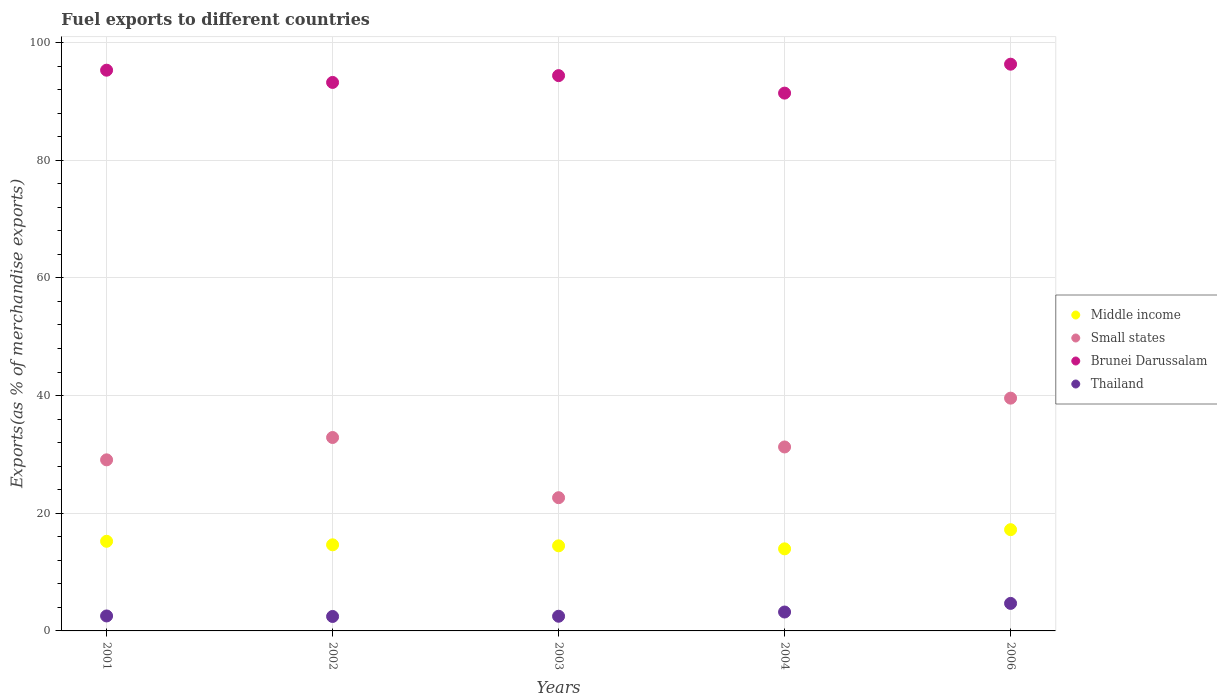How many different coloured dotlines are there?
Give a very brief answer. 4. Is the number of dotlines equal to the number of legend labels?
Provide a short and direct response. Yes. What is the percentage of exports to different countries in Thailand in 2006?
Your answer should be very brief. 4.68. Across all years, what is the maximum percentage of exports to different countries in Thailand?
Your response must be concise. 4.68. Across all years, what is the minimum percentage of exports to different countries in Brunei Darussalam?
Your response must be concise. 91.41. In which year was the percentage of exports to different countries in Brunei Darussalam maximum?
Your answer should be very brief. 2006. What is the total percentage of exports to different countries in Brunei Darussalam in the graph?
Your answer should be compact. 470.65. What is the difference between the percentage of exports to different countries in Thailand in 2001 and that in 2003?
Your answer should be very brief. 0.05. What is the difference between the percentage of exports to different countries in Small states in 2006 and the percentage of exports to different countries in Middle income in 2002?
Ensure brevity in your answer.  24.93. What is the average percentage of exports to different countries in Thailand per year?
Your response must be concise. 3.08. In the year 2006, what is the difference between the percentage of exports to different countries in Brunei Darussalam and percentage of exports to different countries in Thailand?
Offer a very short reply. 91.65. In how many years, is the percentage of exports to different countries in Brunei Darussalam greater than 88 %?
Provide a succinct answer. 5. What is the ratio of the percentage of exports to different countries in Middle income in 2003 to that in 2004?
Your answer should be very brief. 1.04. Is the percentage of exports to different countries in Thailand in 2003 less than that in 2006?
Your answer should be very brief. Yes. Is the difference between the percentage of exports to different countries in Brunei Darussalam in 2002 and 2003 greater than the difference between the percentage of exports to different countries in Thailand in 2002 and 2003?
Your answer should be compact. No. What is the difference between the highest and the second highest percentage of exports to different countries in Brunei Darussalam?
Keep it short and to the point. 1.02. What is the difference between the highest and the lowest percentage of exports to different countries in Thailand?
Offer a terse response. 2.22. In how many years, is the percentage of exports to different countries in Thailand greater than the average percentage of exports to different countries in Thailand taken over all years?
Provide a succinct answer. 2. Is it the case that in every year, the sum of the percentage of exports to different countries in Middle income and percentage of exports to different countries in Small states  is greater than the sum of percentage of exports to different countries in Thailand and percentage of exports to different countries in Brunei Darussalam?
Make the answer very short. Yes. Is the percentage of exports to different countries in Middle income strictly greater than the percentage of exports to different countries in Small states over the years?
Your answer should be very brief. No. Is the percentage of exports to different countries in Small states strictly less than the percentage of exports to different countries in Middle income over the years?
Make the answer very short. No. How many years are there in the graph?
Offer a terse response. 5. What is the difference between two consecutive major ticks on the Y-axis?
Your answer should be very brief. 20. Does the graph contain any zero values?
Keep it short and to the point. No. Does the graph contain grids?
Keep it short and to the point. Yes. Where does the legend appear in the graph?
Keep it short and to the point. Center right. How are the legend labels stacked?
Make the answer very short. Vertical. What is the title of the graph?
Ensure brevity in your answer.  Fuel exports to different countries. Does "Maldives" appear as one of the legend labels in the graph?
Offer a terse response. No. What is the label or title of the Y-axis?
Offer a very short reply. Exports(as % of merchandise exports). What is the Exports(as % of merchandise exports) of Middle income in 2001?
Your response must be concise. 15.23. What is the Exports(as % of merchandise exports) in Small states in 2001?
Offer a very short reply. 29.08. What is the Exports(as % of merchandise exports) of Brunei Darussalam in 2001?
Ensure brevity in your answer.  95.31. What is the Exports(as % of merchandise exports) of Thailand in 2001?
Ensure brevity in your answer.  2.54. What is the Exports(as % of merchandise exports) in Middle income in 2002?
Offer a terse response. 14.63. What is the Exports(as % of merchandise exports) of Small states in 2002?
Your answer should be compact. 32.88. What is the Exports(as % of merchandise exports) of Brunei Darussalam in 2002?
Give a very brief answer. 93.23. What is the Exports(as % of merchandise exports) of Thailand in 2002?
Your answer should be compact. 2.46. What is the Exports(as % of merchandise exports) of Middle income in 2003?
Provide a succinct answer. 14.46. What is the Exports(as % of merchandise exports) of Small states in 2003?
Your answer should be very brief. 22.64. What is the Exports(as % of merchandise exports) of Brunei Darussalam in 2003?
Your response must be concise. 94.38. What is the Exports(as % of merchandise exports) of Thailand in 2003?
Provide a succinct answer. 2.5. What is the Exports(as % of merchandise exports) of Middle income in 2004?
Your response must be concise. 13.95. What is the Exports(as % of merchandise exports) in Small states in 2004?
Make the answer very short. 31.27. What is the Exports(as % of merchandise exports) in Brunei Darussalam in 2004?
Your response must be concise. 91.41. What is the Exports(as % of merchandise exports) of Thailand in 2004?
Keep it short and to the point. 3.21. What is the Exports(as % of merchandise exports) of Middle income in 2006?
Your answer should be compact. 17.21. What is the Exports(as % of merchandise exports) of Small states in 2006?
Keep it short and to the point. 39.56. What is the Exports(as % of merchandise exports) of Brunei Darussalam in 2006?
Give a very brief answer. 96.33. What is the Exports(as % of merchandise exports) of Thailand in 2006?
Give a very brief answer. 4.68. Across all years, what is the maximum Exports(as % of merchandise exports) in Middle income?
Provide a short and direct response. 17.21. Across all years, what is the maximum Exports(as % of merchandise exports) in Small states?
Your answer should be very brief. 39.56. Across all years, what is the maximum Exports(as % of merchandise exports) of Brunei Darussalam?
Your response must be concise. 96.33. Across all years, what is the maximum Exports(as % of merchandise exports) in Thailand?
Make the answer very short. 4.68. Across all years, what is the minimum Exports(as % of merchandise exports) of Middle income?
Keep it short and to the point. 13.95. Across all years, what is the minimum Exports(as % of merchandise exports) of Small states?
Offer a very short reply. 22.64. Across all years, what is the minimum Exports(as % of merchandise exports) in Brunei Darussalam?
Make the answer very short. 91.41. Across all years, what is the minimum Exports(as % of merchandise exports) in Thailand?
Give a very brief answer. 2.46. What is the total Exports(as % of merchandise exports) in Middle income in the graph?
Make the answer very short. 75.49. What is the total Exports(as % of merchandise exports) of Small states in the graph?
Provide a short and direct response. 155.43. What is the total Exports(as % of merchandise exports) of Brunei Darussalam in the graph?
Offer a very short reply. 470.65. What is the total Exports(as % of merchandise exports) in Thailand in the graph?
Offer a very short reply. 15.39. What is the difference between the Exports(as % of merchandise exports) of Middle income in 2001 and that in 2002?
Make the answer very short. 0.6. What is the difference between the Exports(as % of merchandise exports) of Small states in 2001 and that in 2002?
Provide a short and direct response. -3.8. What is the difference between the Exports(as % of merchandise exports) in Brunei Darussalam in 2001 and that in 2002?
Your answer should be very brief. 2.08. What is the difference between the Exports(as % of merchandise exports) of Thailand in 2001 and that in 2002?
Ensure brevity in your answer.  0.09. What is the difference between the Exports(as % of merchandise exports) of Middle income in 2001 and that in 2003?
Provide a short and direct response. 0.77. What is the difference between the Exports(as % of merchandise exports) in Small states in 2001 and that in 2003?
Offer a very short reply. 6.43. What is the difference between the Exports(as % of merchandise exports) in Brunei Darussalam in 2001 and that in 2003?
Provide a succinct answer. 0.92. What is the difference between the Exports(as % of merchandise exports) in Thailand in 2001 and that in 2003?
Make the answer very short. 0.05. What is the difference between the Exports(as % of merchandise exports) of Middle income in 2001 and that in 2004?
Offer a terse response. 1.28. What is the difference between the Exports(as % of merchandise exports) in Small states in 2001 and that in 2004?
Offer a terse response. -2.19. What is the difference between the Exports(as % of merchandise exports) of Brunei Darussalam in 2001 and that in 2004?
Make the answer very short. 3.9. What is the difference between the Exports(as % of merchandise exports) of Thailand in 2001 and that in 2004?
Your answer should be very brief. -0.67. What is the difference between the Exports(as % of merchandise exports) in Middle income in 2001 and that in 2006?
Provide a short and direct response. -1.97. What is the difference between the Exports(as % of merchandise exports) in Small states in 2001 and that in 2006?
Ensure brevity in your answer.  -10.49. What is the difference between the Exports(as % of merchandise exports) in Brunei Darussalam in 2001 and that in 2006?
Your response must be concise. -1.02. What is the difference between the Exports(as % of merchandise exports) in Thailand in 2001 and that in 2006?
Give a very brief answer. -2.13. What is the difference between the Exports(as % of merchandise exports) in Middle income in 2002 and that in 2003?
Offer a very short reply. 0.17. What is the difference between the Exports(as % of merchandise exports) of Small states in 2002 and that in 2003?
Offer a terse response. 10.23. What is the difference between the Exports(as % of merchandise exports) in Brunei Darussalam in 2002 and that in 2003?
Keep it short and to the point. -1.16. What is the difference between the Exports(as % of merchandise exports) in Thailand in 2002 and that in 2003?
Give a very brief answer. -0.04. What is the difference between the Exports(as % of merchandise exports) of Middle income in 2002 and that in 2004?
Give a very brief answer. 0.68. What is the difference between the Exports(as % of merchandise exports) in Small states in 2002 and that in 2004?
Offer a terse response. 1.61. What is the difference between the Exports(as % of merchandise exports) in Brunei Darussalam in 2002 and that in 2004?
Your response must be concise. 1.82. What is the difference between the Exports(as % of merchandise exports) in Thailand in 2002 and that in 2004?
Ensure brevity in your answer.  -0.76. What is the difference between the Exports(as % of merchandise exports) in Middle income in 2002 and that in 2006?
Make the answer very short. -2.57. What is the difference between the Exports(as % of merchandise exports) in Small states in 2002 and that in 2006?
Offer a very short reply. -6.69. What is the difference between the Exports(as % of merchandise exports) in Brunei Darussalam in 2002 and that in 2006?
Provide a short and direct response. -3.1. What is the difference between the Exports(as % of merchandise exports) of Thailand in 2002 and that in 2006?
Ensure brevity in your answer.  -2.22. What is the difference between the Exports(as % of merchandise exports) in Middle income in 2003 and that in 2004?
Keep it short and to the point. 0.51. What is the difference between the Exports(as % of merchandise exports) in Small states in 2003 and that in 2004?
Make the answer very short. -8.62. What is the difference between the Exports(as % of merchandise exports) of Brunei Darussalam in 2003 and that in 2004?
Keep it short and to the point. 2.97. What is the difference between the Exports(as % of merchandise exports) in Thailand in 2003 and that in 2004?
Ensure brevity in your answer.  -0.72. What is the difference between the Exports(as % of merchandise exports) in Middle income in 2003 and that in 2006?
Offer a terse response. -2.75. What is the difference between the Exports(as % of merchandise exports) in Small states in 2003 and that in 2006?
Your answer should be compact. -16.92. What is the difference between the Exports(as % of merchandise exports) of Brunei Darussalam in 2003 and that in 2006?
Your answer should be compact. -1.94. What is the difference between the Exports(as % of merchandise exports) in Thailand in 2003 and that in 2006?
Provide a succinct answer. -2.18. What is the difference between the Exports(as % of merchandise exports) in Middle income in 2004 and that in 2006?
Provide a short and direct response. -3.26. What is the difference between the Exports(as % of merchandise exports) of Small states in 2004 and that in 2006?
Give a very brief answer. -8.3. What is the difference between the Exports(as % of merchandise exports) in Brunei Darussalam in 2004 and that in 2006?
Your response must be concise. -4.92. What is the difference between the Exports(as % of merchandise exports) of Thailand in 2004 and that in 2006?
Offer a very short reply. -1.47. What is the difference between the Exports(as % of merchandise exports) in Middle income in 2001 and the Exports(as % of merchandise exports) in Small states in 2002?
Provide a short and direct response. -17.64. What is the difference between the Exports(as % of merchandise exports) in Middle income in 2001 and the Exports(as % of merchandise exports) in Brunei Darussalam in 2002?
Ensure brevity in your answer.  -77.99. What is the difference between the Exports(as % of merchandise exports) in Middle income in 2001 and the Exports(as % of merchandise exports) in Thailand in 2002?
Your response must be concise. 12.78. What is the difference between the Exports(as % of merchandise exports) of Small states in 2001 and the Exports(as % of merchandise exports) of Brunei Darussalam in 2002?
Make the answer very short. -64.15. What is the difference between the Exports(as % of merchandise exports) of Small states in 2001 and the Exports(as % of merchandise exports) of Thailand in 2002?
Offer a terse response. 26.62. What is the difference between the Exports(as % of merchandise exports) in Brunei Darussalam in 2001 and the Exports(as % of merchandise exports) in Thailand in 2002?
Provide a succinct answer. 92.85. What is the difference between the Exports(as % of merchandise exports) in Middle income in 2001 and the Exports(as % of merchandise exports) in Small states in 2003?
Offer a terse response. -7.41. What is the difference between the Exports(as % of merchandise exports) of Middle income in 2001 and the Exports(as % of merchandise exports) of Brunei Darussalam in 2003?
Provide a short and direct response. -79.15. What is the difference between the Exports(as % of merchandise exports) of Middle income in 2001 and the Exports(as % of merchandise exports) of Thailand in 2003?
Keep it short and to the point. 12.74. What is the difference between the Exports(as % of merchandise exports) in Small states in 2001 and the Exports(as % of merchandise exports) in Brunei Darussalam in 2003?
Make the answer very short. -65.3. What is the difference between the Exports(as % of merchandise exports) in Small states in 2001 and the Exports(as % of merchandise exports) in Thailand in 2003?
Give a very brief answer. 26.58. What is the difference between the Exports(as % of merchandise exports) of Brunei Darussalam in 2001 and the Exports(as % of merchandise exports) of Thailand in 2003?
Your response must be concise. 92.81. What is the difference between the Exports(as % of merchandise exports) in Middle income in 2001 and the Exports(as % of merchandise exports) in Small states in 2004?
Provide a short and direct response. -16.03. What is the difference between the Exports(as % of merchandise exports) of Middle income in 2001 and the Exports(as % of merchandise exports) of Brunei Darussalam in 2004?
Give a very brief answer. -76.17. What is the difference between the Exports(as % of merchandise exports) of Middle income in 2001 and the Exports(as % of merchandise exports) of Thailand in 2004?
Give a very brief answer. 12.02. What is the difference between the Exports(as % of merchandise exports) of Small states in 2001 and the Exports(as % of merchandise exports) of Brunei Darussalam in 2004?
Keep it short and to the point. -62.33. What is the difference between the Exports(as % of merchandise exports) in Small states in 2001 and the Exports(as % of merchandise exports) in Thailand in 2004?
Your response must be concise. 25.86. What is the difference between the Exports(as % of merchandise exports) of Brunei Darussalam in 2001 and the Exports(as % of merchandise exports) of Thailand in 2004?
Keep it short and to the point. 92.09. What is the difference between the Exports(as % of merchandise exports) of Middle income in 2001 and the Exports(as % of merchandise exports) of Small states in 2006?
Your answer should be compact. -24.33. What is the difference between the Exports(as % of merchandise exports) of Middle income in 2001 and the Exports(as % of merchandise exports) of Brunei Darussalam in 2006?
Give a very brief answer. -81.09. What is the difference between the Exports(as % of merchandise exports) in Middle income in 2001 and the Exports(as % of merchandise exports) in Thailand in 2006?
Your answer should be compact. 10.56. What is the difference between the Exports(as % of merchandise exports) of Small states in 2001 and the Exports(as % of merchandise exports) of Brunei Darussalam in 2006?
Provide a succinct answer. -67.25. What is the difference between the Exports(as % of merchandise exports) in Small states in 2001 and the Exports(as % of merchandise exports) in Thailand in 2006?
Give a very brief answer. 24.4. What is the difference between the Exports(as % of merchandise exports) in Brunei Darussalam in 2001 and the Exports(as % of merchandise exports) in Thailand in 2006?
Ensure brevity in your answer.  90.63. What is the difference between the Exports(as % of merchandise exports) in Middle income in 2002 and the Exports(as % of merchandise exports) in Small states in 2003?
Your response must be concise. -8.01. What is the difference between the Exports(as % of merchandise exports) of Middle income in 2002 and the Exports(as % of merchandise exports) of Brunei Darussalam in 2003?
Your response must be concise. -79.75. What is the difference between the Exports(as % of merchandise exports) in Middle income in 2002 and the Exports(as % of merchandise exports) in Thailand in 2003?
Keep it short and to the point. 12.14. What is the difference between the Exports(as % of merchandise exports) in Small states in 2002 and the Exports(as % of merchandise exports) in Brunei Darussalam in 2003?
Give a very brief answer. -61.51. What is the difference between the Exports(as % of merchandise exports) in Small states in 2002 and the Exports(as % of merchandise exports) in Thailand in 2003?
Ensure brevity in your answer.  30.38. What is the difference between the Exports(as % of merchandise exports) of Brunei Darussalam in 2002 and the Exports(as % of merchandise exports) of Thailand in 2003?
Your answer should be compact. 90.73. What is the difference between the Exports(as % of merchandise exports) in Middle income in 2002 and the Exports(as % of merchandise exports) in Small states in 2004?
Offer a very short reply. -16.63. What is the difference between the Exports(as % of merchandise exports) in Middle income in 2002 and the Exports(as % of merchandise exports) in Brunei Darussalam in 2004?
Your answer should be compact. -76.77. What is the difference between the Exports(as % of merchandise exports) in Middle income in 2002 and the Exports(as % of merchandise exports) in Thailand in 2004?
Your response must be concise. 11.42. What is the difference between the Exports(as % of merchandise exports) in Small states in 2002 and the Exports(as % of merchandise exports) in Brunei Darussalam in 2004?
Keep it short and to the point. -58.53. What is the difference between the Exports(as % of merchandise exports) in Small states in 2002 and the Exports(as % of merchandise exports) in Thailand in 2004?
Your answer should be compact. 29.66. What is the difference between the Exports(as % of merchandise exports) of Brunei Darussalam in 2002 and the Exports(as % of merchandise exports) of Thailand in 2004?
Give a very brief answer. 90.01. What is the difference between the Exports(as % of merchandise exports) in Middle income in 2002 and the Exports(as % of merchandise exports) in Small states in 2006?
Your answer should be very brief. -24.93. What is the difference between the Exports(as % of merchandise exports) of Middle income in 2002 and the Exports(as % of merchandise exports) of Brunei Darussalam in 2006?
Offer a terse response. -81.69. What is the difference between the Exports(as % of merchandise exports) in Middle income in 2002 and the Exports(as % of merchandise exports) in Thailand in 2006?
Your answer should be compact. 9.96. What is the difference between the Exports(as % of merchandise exports) in Small states in 2002 and the Exports(as % of merchandise exports) in Brunei Darussalam in 2006?
Make the answer very short. -63.45. What is the difference between the Exports(as % of merchandise exports) in Small states in 2002 and the Exports(as % of merchandise exports) in Thailand in 2006?
Your answer should be compact. 28.2. What is the difference between the Exports(as % of merchandise exports) of Brunei Darussalam in 2002 and the Exports(as % of merchandise exports) of Thailand in 2006?
Offer a very short reply. 88.55. What is the difference between the Exports(as % of merchandise exports) of Middle income in 2003 and the Exports(as % of merchandise exports) of Small states in 2004?
Ensure brevity in your answer.  -16.8. What is the difference between the Exports(as % of merchandise exports) of Middle income in 2003 and the Exports(as % of merchandise exports) of Brunei Darussalam in 2004?
Your response must be concise. -76.95. What is the difference between the Exports(as % of merchandise exports) of Middle income in 2003 and the Exports(as % of merchandise exports) of Thailand in 2004?
Offer a very short reply. 11.25. What is the difference between the Exports(as % of merchandise exports) in Small states in 2003 and the Exports(as % of merchandise exports) in Brunei Darussalam in 2004?
Make the answer very short. -68.77. What is the difference between the Exports(as % of merchandise exports) of Small states in 2003 and the Exports(as % of merchandise exports) of Thailand in 2004?
Provide a short and direct response. 19.43. What is the difference between the Exports(as % of merchandise exports) in Brunei Darussalam in 2003 and the Exports(as % of merchandise exports) in Thailand in 2004?
Your answer should be compact. 91.17. What is the difference between the Exports(as % of merchandise exports) of Middle income in 2003 and the Exports(as % of merchandise exports) of Small states in 2006?
Provide a short and direct response. -25.1. What is the difference between the Exports(as % of merchandise exports) in Middle income in 2003 and the Exports(as % of merchandise exports) in Brunei Darussalam in 2006?
Offer a terse response. -81.86. What is the difference between the Exports(as % of merchandise exports) of Middle income in 2003 and the Exports(as % of merchandise exports) of Thailand in 2006?
Give a very brief answer. 9.78. What is the difference between the Exports(as % of merchandise exports) in Small states in 2003 and the Exports(as % of merchandise exports) in Brunei Darussalam in 2006?
Keep it short and to the point. -73.68. What is the difference between the Exports(as % of merchandise exports) in Small states in 2003 and the Exports(as % of merchandise exports) in Thailand in 2006?
Keep it short and to the point. 17.96. What is the difference between the Exports(as % of merchandise exports) of Brunei Darussalam in 2003 and the Exports(as % of merchandise exports) of Thailand in 2006?
Your response must be concise. 89.7. What is the difference between the Exports(as % of merchandise exports) in Middle income in 2004 and the Exports(as % of merchandise exports) in Small states in 2006?
Offer a very short reply. -25.61. What is the difference between the Exports(as % of merchandise exports) of Middle income in 2004 and the Exports(as % of merchandise exports) of Brunei Darussalam in 2006?
Give a very brief answer. -82.38. What is the difference between the Exports(as % of merchandise exports) of Middle income in 2004 and the Exports(as % of merchandise exports) of Thailand in 2006?
Offer a very short reply. 9.27. What is the difference between the Exports(as % of merchandise exports) in Small states in 2004 and the Exports(as % of merchandise exports) in Brunei Darussalam in 2006?
Offer a terse response. -65.06. What is the difference between the Exports(as % of merchandise exports) in Small states in 2004 and the Exports(as % of merchandise exports) in Thailand in 2006?
Provide a succinct answer. 26.59. What is the difference between the Exports(as % of merchandise exports) in Brunei Darussalam in 2004 and the Exports(as % of merchandise exports) in Thailand in 2006?
Ensure brevity in your answer.  86.73. What is the average Exports(as % of merchandise exports) in Middle income per year?
Your response must be concise. 15.1. What is the average Exports(as % of merchandise exports) in Small states per year?
Make the answer very short. 31.09. What is the average Exports(as % of merchandise exports) of Brunei Darussalam per year?
Make the answer very short. 94.13. What is the average Exports(as % of merchandise exports) in Thailand per year?
Provide a succinct answer. 3.08. In the year 2001, what is the difference between the Exports(as % of merchandise exports) in Middle income and Exports(as % of merchandise exports) in Small states?
Provide a short and direct response. -13.84. In the year 2001, what is the difference between the Exports(as % of merchandise exports) in Middle income and Exports(as % of merchandise exports) in Brunei Darussalam?
Provide a short and direct response. -80.07. In the year 2001, what is the difference between the Exports(as % of merchandise exports) of Middle income and Exports(as % of merchandise exports) of Thailand?
Offer a terse response. 12.69. In the year 2001, what is the difference between the Exports(as % of merchandise exports) of Small states and Exports(as % of merchandise exports) of Brunei Darussalam?
Your response must be concise. -66.23. In the year 2001, what is the difference between the Exports(as % of merchandise exports) in Small states and Exports(as % of merchandise exports) in Thailand?
Your answer should be very brief. 26.53. In the year 2001, what is the difference between the Exports(as % of merchandise exports) of Brunei Darussalam and Exports(as % of merchandise exports) of Thailand?
Make the answer very short. 92.76. In the year 2002, what is the difference between the Exports(as % of merchandise exports) of Middle income and Exports(as % of merchandise exports) of Small states?
Keep it short and to the point. -18.24. In the year 2002, what is the difference between the Exports(as % of merchandise exports) of Middle income and Exports(as % of merchandise exports) of Brunei Darussalam?
Provide a succinct answer. -78.59. In the year 2002, what is the difference between the Exports(as % of merchandise exports) of Middle income and Exports(as % of merchandise exports) of Thailand?
Your response must be concise. 12.18. In the year 2002, what is the difference between the Exports(as % of merchandise exports) of Small states and Exports(as % of merchandise exports) of Brunei Darussalam?
Your answer should be compact. -60.35. In the year 2002, what is the difference between the Exports(as % of merchandise exports) of Small states and Exports(as % of merchandise exports) of Thailand?
Offer a very short reply. 30.42. In the year 2002, what is the difference between the Exports(as % of merchandise exports) in Brunei Darussalam and Exports(as % of merchandise exports) in Thailand?
Keep it short and to the point. 90.77. In the year 2003, what is the difference between the Exports(as % of merchandise exports) in Middle income and Exports(as % of merchandise exports) in Small states?
Provide a short and direct response. -8.18. In the year 2003, what is the difference between the Exports(as % of merchandise exports) in Middle income and Exports(as % of merchandise exports) in Brunei Darussalam?
Provide a succinct answer. -79.92. In the year 2003, what is the difference between the Exports(as % of merchandise exports) in Middle income and Exports(as % of merchandise exports) in Thailand?
Make the answer very short. 11.97. In the year 2003, what is the difference between the Exports(as % of merchandise exports) of Small states and Exports(as % of merchandise exports) of Brunei Darussalam?
Provide a short and direct response. -71.74. In the year 2003, what is the difference between the Exports(as % of merchandise exports) of Small states and Exports(as % of merchandise exports) of Thailand?
Your response must be concise. 20.15. In the year 2003, what is the difference between the Exports(as % of merchandise exports) of Brunei Darussalam and Exports(as % of merchandise exports) of Thailand?
Offer a very short reply. 91.89. In the year 2004, what is the difference between the Exports(as % of merchandise exports) of Middle income and Exports(as % of merchandise exports) of Small states?
Give a very brief answer. -17.32. In the year 2004, what is the difference between the Exports(as % of merchandise exports) in Middle income and Exports(as % of merchandise exports) in Brunei Darussalam?
Offer a very short reply. -77.46. In the year 2004, what is the difference between the Exports(as % of merchandise exports) in Middle income and Exports(as % of merchandise exports) in Thailand?
Keep it short and to the point. 10.74. In the year 2004, what is the difference between the Exports(as % of merchandise exports) in Small states and Exports(as % of merchandise exports) in Brunei Darussalam?
Offer a terse response. -60.14. In the year 2004, what is the difference between the Exports(as % of merchandise exports) of Small states and Exports(as % of merchandise exports) of Thailand?
Your answer should be compact. 28.05. In the year 2004, what is the difference between the Exports(as % of merchandise exports) in Brunei Darussalam and Exports(as % of merchandise exports) in Thailand?
Make the answer very short. 88.2. In the year 2006, what is the difference between the Exports(as % of merchandise exports) of Middle income and Exports(as % of merchandise exports) of Small states?
Your answer should be compact. -22.35. In the year 2006, what is the difference between the Exports(as % of merchandise exports) in Middle income and Exports(as % of merchandise exports) in Brunei Darussalam?
Offer a terse response. -79.12. In the year 2006, what is the difference between the Exports(as % of merchandise exports) in Middle income and Exports(as % of merchandise exports) in Thailand?
Your answer should be very brief. 12.53. In the year 2006, what is the difference between the Exports(as % of merchandise exports) of Small states and Exports(as % of merchandise exports) of Brunei Darussalam?
Ensure brevity in your answer.  -56.76. In the year 2006, what is the difference between the Exports(as % of merchandise exports) in Small states and Exports(as % of merchandise exports) in Thailand?
Your answer should be very brief. 34.88. In the year 2006, what is the difference between the Exports(as % of merchandise exports) of Brunei Darussalam and Exports(as % of merchandise exports) of Thailand?
Offer a terse response. 91.65. What is the ratio of the Exports(as % of merchandise exports) in Middle income in 2001 to that in 2002?
Keep it short and to the point. 1.04. What is the ratio of the Exports(as % of merchandise exports) in Small states in 2001 to that in 2002?
Offer a terse response. 0.88. What is the ratio of the Exports(as % of merchandise exports) of Brunei Darussalam in 2001 to that in 2002?
Keep it short and to the point. 1.02. What is the ratio of the Exports(as % of merchandise exports) in Thailand in 2001 to that in 2002?
Make the answer very short. 1.04. What is the ratio of the Exports(as % of merchandise exports) in Middle income in 2001 to that in 2003?
Offer a terse response. 1.05. What is the ratio of the Exports(as % of merchandise exports) of Small states in 2001 to that in 2003?
Make the answer very short. 1.28. What is the ratio of the Exports(as % of merchandise exports) in Brunei Darussalam in 2001 to that in 2003?
Give a very brief answer. 1.01. What is the ratio of the Exports(as % of merchandise exports) in Thailand in 2001 to that in 2003?
Offer a very short reply. 1.02. What is the ratio of the Exports(as % of merchandise exports) in Middle income in 2001 to that in 2004?
Give a very brief answer. 1.09. What is the ratio of the Exports(as % of merchandise exports) in Small states in 2001 to that in 2004?
Your answer should be very brief. 0.93. What is the ratio of the Exports(as % of merchandise exports) in Brunei Darussalam in 2001 to that in 2004?
Ensure brevity in your answer.  1.04. What is the ratio of the Exports(as % of merchandise exports) of Thailand in 2001 to that in 2004?
Offer a very short reply. 0.79. What is the ratio of the Exports(as % of merchandise exports) of Middle income in 2001 to that in 2006?
Keep it short and to the point. 0.89. What is the ratio of the Exports(as % of merchandise exports) of Small states in 2001 to that in 2006?
Provide a short and direct response. 0.73. What is the ratio of the Exports(as % of merchandise exports) in Brunei Darussalam in 2001 to that in 2006?
Your answer should be compact. 0.99. What is the ratio of the Exports(as % of merchandise exports) of Thailand in 2001 to that in 2006?
Give a very brief answer. 0.54. What is the ratio of the Exports(as % of merchandise exports) of Middle income in 2002 to that in 2003?
Make the answer very short. 1.01. What is the ratio of the Exports(as % of merchandise exports) in Small states in 2002 to that in 2003?
Offer a very short reply. 1.45. What is the ratio of the Exports(as % of merchandise exports) of Middle income in 2002 to that in 2004?
Offer a terse response. 1.05. What is the ratio of the Exports(as % of merchandise exports) in Small states in 2002 to that in 2004?
Offer a terse response. 1.05. What is the ratio of the Exports(as % of merchandise exports) in Brunei Darussalam in 2002 to that in 2004?
Provide a succinct answer. 1.02. What is the ratio of the Exports(as % of merchandise exports) of Thailand in 2002 to that in 2004?
Keep it short and to the point. 0.76. What is the ratio of the Exports(as % of merchandise exports) in Middle income in 2002 to that in 2006?
Keep it short and to the point. 0.85. What is the ratio of the Exports(as % of merchandise exports) in Small states in 2002 to that in 2006?
Make the answer very short. 0.83. What is the ratio of the Exports(as % of merchandise exports) of Brunei Darussalam in 2002 to that in 2006?
Keep it short and to the point. 0.97. What is the ratio of the Exports(as % of merchandise exports) in Thailand in 2002 to that in 2006?
Provide a succinct answer. 0.53. What is the ratio of the Exports(as % of merchandise exports) of Middle income in 2003 to that in 2004?
Offer a very short reply. 1.04. What is the ratio of the Exports(as % of merchandise exports) of Small states in 2003 to that in 2004?
Make the answer very short. 0.72. What is the ratio of the Exports(as % of merchandise exports) of Brunei Darussalam in 2003 to that in 2004?
Offer a terse response. 1.03. What is the ratio of the Exports(as % of merchandise exports) of Thailand in 2003 to that in 2004?
Ensure brevity in your answer.  0.78. What is the ratio of the Exports(as % of merchandise exports) in Middle income in 2003 to that in 2006?
Offer a terse response. 0.84. What is the ratio of the Exports(as % of merchandise exports) in Small states in 2003 to that in 2006?
Ensure brevity in your answer.  0.57. What is the ratio of the Exports(as % of merchandise exports) in Brunei Darussalam in 2003 to that in 2006?
Give a very brief answer. 0.98. What is the ratio of the Exports(as % of merchandise exports) in Thailand in 2003 to that in 2006?
Provide a short and direct response. 0.53. What is the ratio of the Exports(as % of merchandise exports) of Middle income in 2004 to that in 2006?
Make the answer very short. 0.81. What is the ratio of the Exports(as % of merchandise exports) in Small states in 2004 to that in 2006?
Keep it short and to the point. 0.79. What is the ratio of the Exports(as % of merchandise exports) of Brunei Darussalam in 2004 to that in 2006?
Your answer should be very brief. 0.95. What is the ratio of the Exports(as % of merchandise exports) in Thailand in 2004 to that in 2006?
Provide a succinct answer. 0.69. What is the difference between the highest and the second highest Exports(as % of merchandise exports) of Middle income?
Your response must be concise. 1.97. What is the difference between the highest and the second highest Exports(as % of merchandise exports) in Small states?
Provide a short and direct response. 6.69. What is the difference between the highest and the second highest Exports(as % of merchandise exports) of Brunei Darussalam?
Provide a succinct answer. 1.02. What is the difference between the highest and the second highest Exports(as % of merchandise exports) of Thailand?
Provide a succinct answer. 1.47. What is the difference between the highest and the lowest Exports(as % of merchandise exports) in Middle income?
Offer a very short reply. 3.26. What is the difference between the highest and the lowest Exports(as % of merchandise exports) in Small states?
Provide a short and direct response. 16.92. What is the difference between the highest and the lowest Exports(as % of merchandise exports) in Brunei Darussalam?
Keep it short and to the point. 4.92. What is the difference between the highest and the lowest Exports(as % of merchandise exports) of Thailand?
Provide a succinct answer. 2.22. 